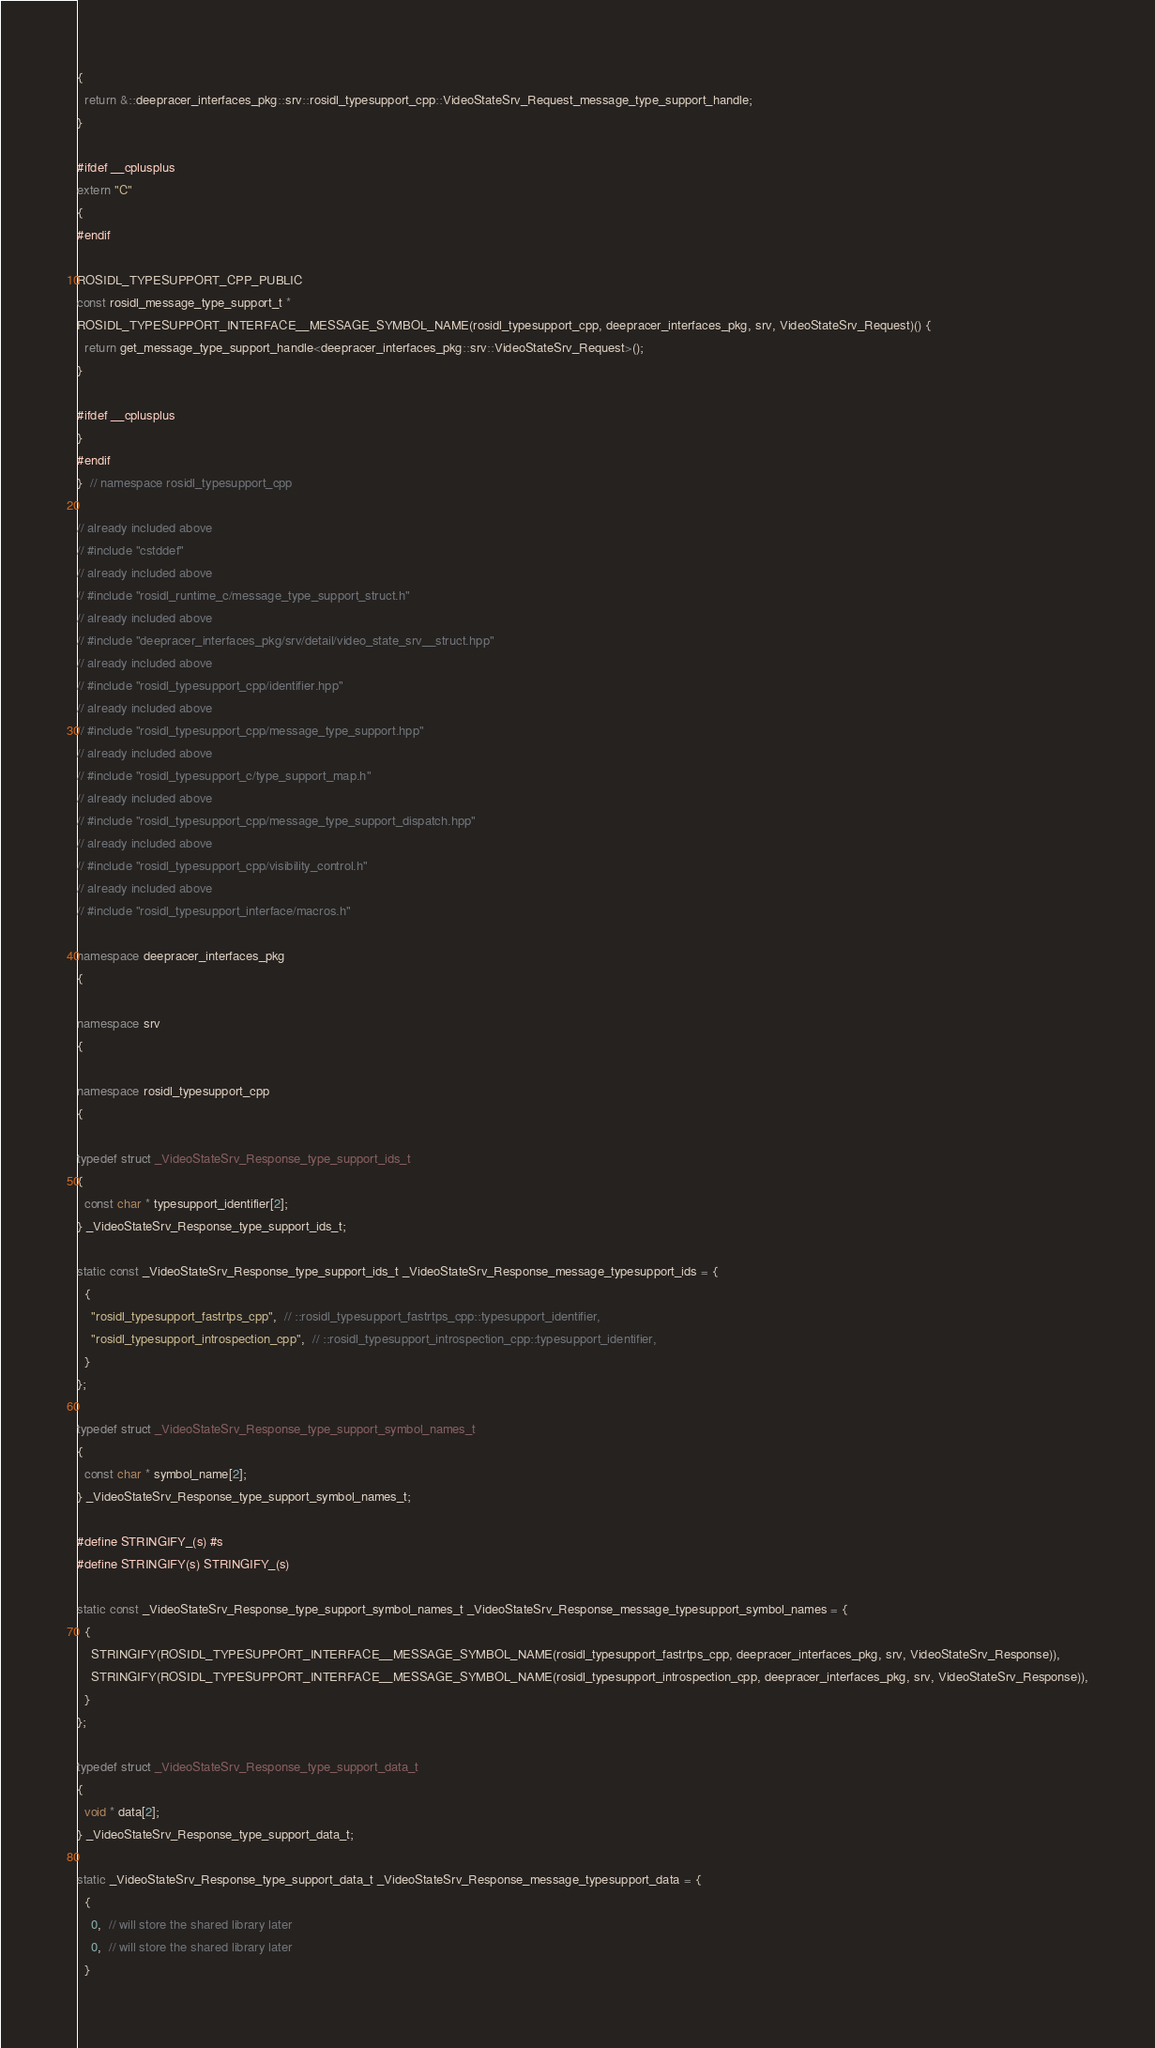Convert code to text. <code><loc_0><loc_0><loc_500><loc_500><_C++_>{
  return &::deepracer_interfaces_pkg::srv::rosidl_typesupport_cpp::VideoStateSrv_Request_message_type_support_handle;
}

#ifdef __cplusplus
extern "C"
{
#endif

ROSIDL_TYPESUPPORT_CPP_PUBLIC
const rosidl_message_type_support_t *
ROSIDL_TYPESUPPORT_INTERFACE__MESSAGE_SYMBOL_NAME(rosidl_typesupport_cpp, deepracer_interfaces_pkg, srv, VideoStateSrv_Request)() {
  return get_message_type_support_handle<deepracer_interfaces_pkg::srv::VideoStateSrv_Request>();
}

#ifdef __cplusplus
}
#endif
}  // namespace rosidl_typesupport_cpp

// already included above
// #include "cstddef"
// already included above
// #include "rosidl_runtime_c/message_type_support_struct.h"
// already included above
// #include "deepracer_interfaces_pkg/srv/detail/video_state_srv__struct.hpp"
// already included above
// #include "rosidl_typesupport_cpp/identifier.hpp"
// already included above
// #include "rosidl_typesupport_cpp/message_type_support.hpp"
// already included above
// #include "rosidl_typesupport_c/type_support_map.h"
// already included above
// #include "rosidl_typesupport_cpp/message_type_support_dispatch.hpp"
// already included above
// #include "rosidl_typesupport_cpp/visibility_control.h"
// already included above
// #include "rosidl_typesupport_interface/macros.h"

namespace deepracer_interfaces_pkg
{

namespace srv
{

namespace rosidl_typesupport_cpp
{

typedef struct _VideoStateSrv_Response_type_support_ids_t
{
  const char * typesupport_identifier[2];
} _VideoStateSrv_Response_type_support_ids_t;

static const _VideoStateSrv_Response_type_support_ids_t _VideoStateSrv_Response_message_typesupport_ids = {
  {
    "rosidl_typesupport_fastrtps_cpp",  // ::rosidl_typesupport_fastrtps_cpp::typesupport_identifier,
    "rosidl_typesupport_introspection_cpp",  // ::rosidl_typesupport_introspection_cpp::typesupport_identifier,
  }
};

typedef struct _VideoStateSrv_Response_type_support_symbol_names_t
{
  const char * symbol_name[2];
} _VideoStateSrv_Response_type_support_symbol_names_t;

#define STRINGIFY_(s) #s
#define STRINGIFY(s) STRINGIFY_(s)

static const _VideoStateSrv_Response_type_support_symbol_names_t _VideoStateSrv_Response_message_typesupport_symbol_names = {
  {
    STRINGIFY(ROSIDL_TYPESUPPORT_INTERFACE__MESSAGE_SYMBOL_NAME(rosidl_typesupport_fastrtps_cpp, deepracer_interfaces_pkg, srv, VideoStateSrv_Response)),
    STRINGIFY(ROSIDL_TYPESUPPORT_INTERFACE__MESSAGE_SYMBOL_NAME(rosidl_typesupport_introspection_cpp, deepracer_interfaces_pkg, srv, VideoStateSrv_Response)),
  }
};

typedef struct _VideoStateSrv_Response_type_support_data_t
{
  void * data[2];
} _VideoStateSrv_Response_type_support_data_t;

static _VideoStateSrv_Response_type_support_data_t _VideoStateSrv_Response_message_typesupport_data = {
  {
    0,  // will store the shared library later
    0,  // will store the shared library later
  }</code> 